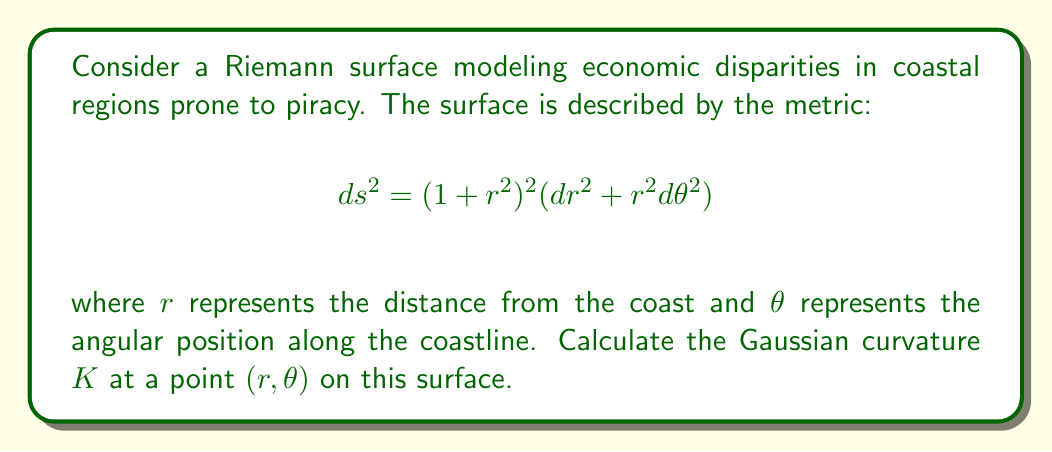Could you help me with this problem? To calculate the Gaussian curvature of this Riemann surface, we'll follow these steps:

1) First, we need to identify the components of the metric tensor:
   $g_{rr} = (1+r^2)^2$
   $g_{\theta\theta} = (1+r^2)^2r^2$
   $g_{r\theta} = g_{\theta r} = 0$

2) The inverse metric tensor is:
   $g^{rr} = \frac{1}{(1+r^2)^2}$
   $g^{\theta\theta} = \frac{1}{(1+r^2)^2r^2}$
   $g^{r\theta} = g^{\theta r} = 0$

3) Next, we need to calculate the Christoffel symbols:
   $\Gamma^r_{rr} = \frac{2r}{1+r^2}$
   $\Gamma^r_{\theta\theta} = -r$
   $\Gamma^\theta_{r\theta} = \Gamma^\theta_{\theta r} = \frac{1}{r} + \frac{2r}{1+r^2}$

4) Now we can calculate the components of the Riemann curvature tensor:
   $R^r_{\theta r\theta} = \partial_r\Gamma^r_{\theta\theta} - \partial_\theta\Gamma^r_{r\theta} + \Gamma^r_{r\theta}\Gamma^r_{\theta\theta} - \Gamma^r_{\theta r}\Gamma^r_{r\theta}$
   $R^r_{\theta r\theta} = -1 - 0 + 0 - 0 = -1$

5) The Gaussian curvature is given by:
   $K = \frac{R^r_{\theta r\theta}}{g_{rr}g_{\theta\theta} - g_{r\theta}^2}$

6) Substituting the values:
   $K = \frac{-1}{(1+r^2)^4r^2 - 0} = -\frac{1}{(1+r^2)^4r^2}$

This expression gives the Gaussian curvature at any point $(r, \theta)$ on the surface.
Answer: $K = -\frac{1}{(1+r^2)^4r^2}$ 